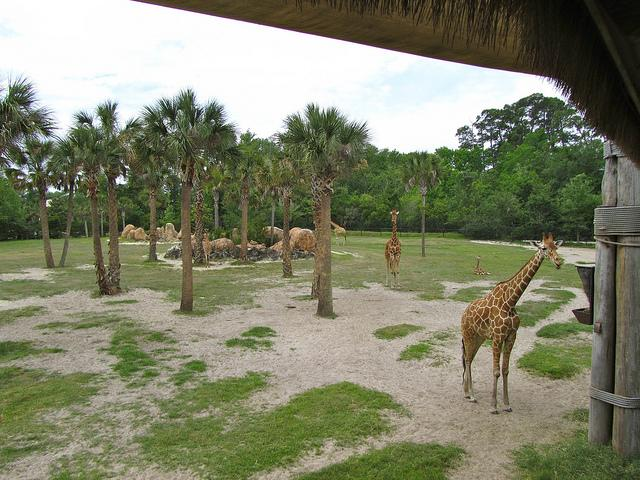What kind of structure is the animal all the way to the right looking at? Please explain your reasoning. wooden. The structure is made of wood logs. 